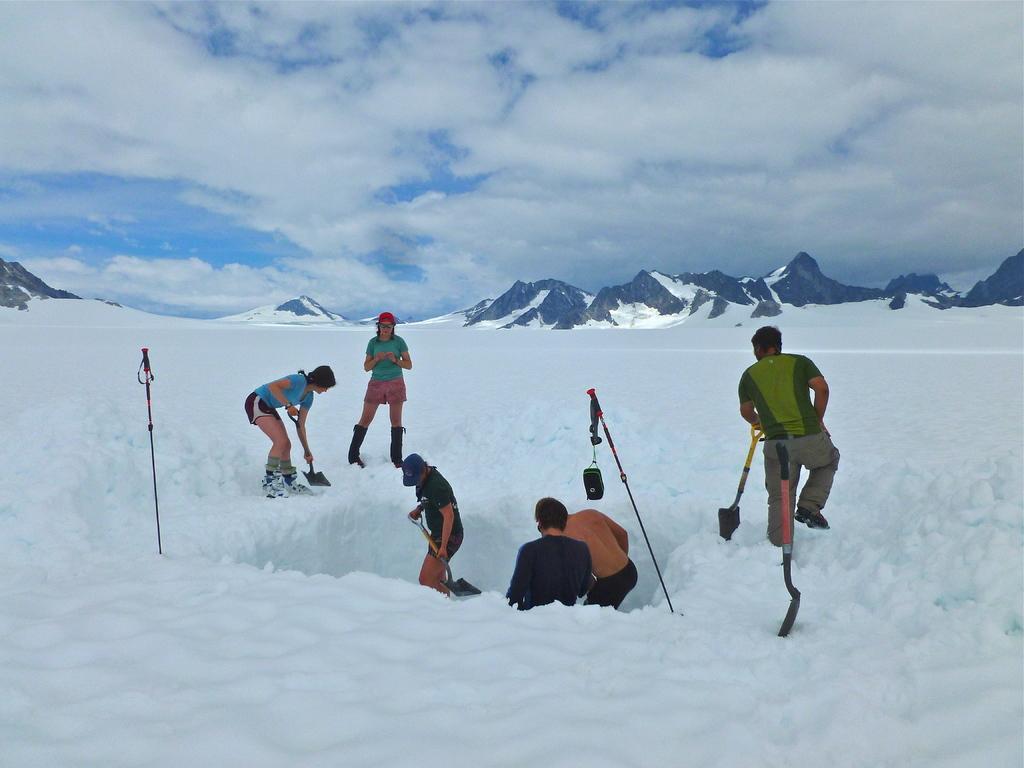Please provide a concise description of this image. In the image we can see there are people standing on the ground and the ground is covered with snow. There are sticks kept on the snow and the people are holding an iron object in their hands. Behind there are mountains and there is a cloudy sky. 